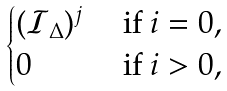<formula> <loc_0><loc_0><loc_500><loc_500>\begin{cases} ( \mathcal { I } _ { \Delta } ) ^ { j } & \text { if } i = 0 , \\ 0 & \text { if } i > 0 , \end{cases}</formula> 